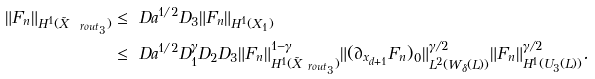<formula> <loc_0><loc_0><loc_500><loc_500>\| F _ { n } \| _ { H ^ { 1 } ( \tilde { X } _ { \ r o u t _ { 3 } } ) } & \leq \ D a ^ { 1 / 2 } D _ { 3 } \| F _ { n } \| _ { H ^ { 1 } ( X _ { 1 } ) } \\ & \leq \ D a ^ { 1 / 2 } D _ { 1 } ^ { \gamma } D _ { 2 } D _ { 3 } \| F _ { n } \| _ { H ^ { 1 } ( \tilde { X } _ { \ r o u t _ { 3 } } ) } ^ { 1 - \gamma } \| ( \partial _ { x _ { d + 1 } } F _ { n } ) _ { 0 } \| _ { L ^ { 2 } ( W _ { \delta } ( L ) ) } ^ { \gamma / 2 } \| F _ { n } \| _ { H ^ { 1 } ( U _ { 3 } ( L ) ) } ^ { \gamma / 2 } .</formula> 